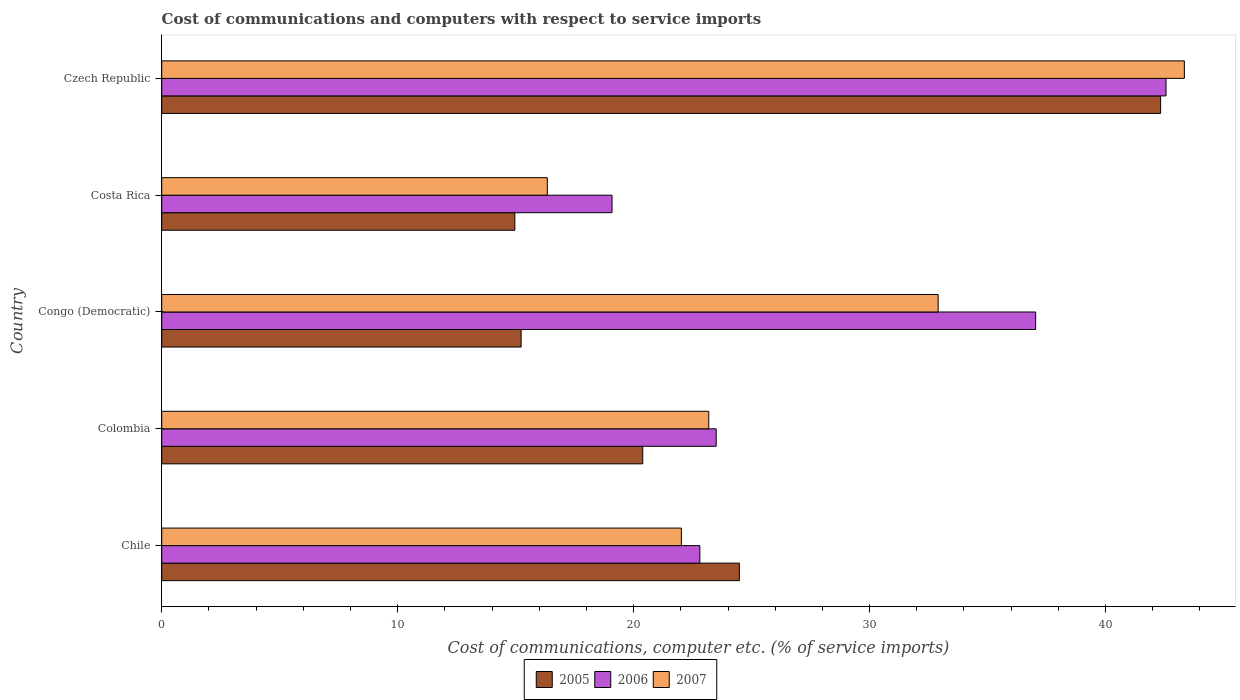How many different coloured bars are there?
Keep it short and to the point. 3. How many bars are there on the 3rd tick from the top?
Keep it short and to the point. 3. What is the label of the 5th group of bars from the top?
Your answer should be very brief. Chile. In how many cases, is the number of bars for a given country not equal to the number of legend labels?
Offer a terse response. 0. What is the cost of communications and computers in 2007 in Congo (Democratic)?
Provide a succinct answer. 32.91. Across all countries, what is the maximum cost of communications and computers in 2006?
Provide a short and direct response. 42.56. Across all countries, what is the minimum cost of communications and computers in 2007?
Keep it short and to the point. 16.34. In which country was the cost of communications and computers in 2007 maximum?
Offer a terse response. Czech Republic. In which country was the cost of communications and computers in 2006 minimum?
Give a very brief answer. Costa Rica. What is the total cost of communications and computers in 2006 in the graph?
Your answer should be compact. 145. What is the difference between the cost of communications and computers in 2006 in Chile and that in Congo (Democratic)?
Ensure brevity in your answer.  -14.23. What is the difference between the cost of communications and computers in 2006 in Czech Republic and the cost of communications and computers in 2007 in Costa Rica?
Your response must be concise. 26.22. What is the average cost of communications and computers in 2007 per country?
Your response must be concise. 27.56. What is the difference between the cost of communications and computers in 2005 and cost of communications and computers in 2006 in Colombia?
Make the answer very short. -3.11. In how many countries, is the cost of communications and computers in 2005 greater than 38 %?
Give a very brief answer. 1. What is the ratio of the cost of communications and computers in 2007 in Chile to that in Colombia?
Ensure brevity in your answer.  0.95. Is the cost of communications and computers in 2006 in Chile less than that in Costa Rica?
Offer a terse response. No. What is the difference between the highest and the second highest cost of communications and computers in 2007?
Offer a very short reply. 10.43. What is the difference between the highest and the lowest cost of communications and computers in 2005?
Provide a short and direct response. 27.37. In how many countries, is the cost of communications and computers in 2007 greater than the average cost of communications and computers in 2007 taken over all countries?
Provide a succinct answer. 2. Is the sum of the cost of communications and computers in 2005 in Colombia and Czech Republic greater than the maximum cost of communications and computers in 2006 across all countries?
Your answer should be compact. Yes. What does the 2nd bar from the top in Costa Rica represents?
Ensure brevity in your answer.  2006. Is it the case that in every country, the sum of the cost of communications and computers in 2005 and cost of communications and computers in 2007 is greater than the cost of communications and computers in 2006?
Your response must be concise. Yes. How many bars are there?
Keep it short and to the point. 15. Are all the bars in the graph horizontal?
Offer a very short reply. Yes. How many countries are there in the graph?
Offer a terse response. 5. What is the difference between two consecutive major ticks on the X-axis?
Give a very brief answer. 10. Does the graph contain any zero values?
Offer a very short reply. No. How many legend labels are there?
Provide a short and direct response. 3. What is the title of the graph?
Your answer should be very brief. Cost of communications and computers with respect to service imports. Does "1966" appear as one of the legend labels in the graph?
Your response must be concise. No. What is the label or title of the X-axis?
Offer a terse response. Cost of communications, computer etc. (% of service imports). What is the label or title of the Y-axis?
Offer a terse response. Country. What is the Cost of communications, computer etc. (% of service imports) of 2005 in Chile?
Provide a short and direct response. 24.48. What is the Cost of communications, computer etc. (% of service imports) of 2006 in Chile?
Ensure brevity in your answer.  22.81. What is the Cost of communications, computer etc. (% of service imports) in 2007 in Chile?
Make the answer very short. 22.02. What is the Cost of communications, computer etc. (% of service imports) in 2005 in Colombia?
Provide a short and direct response. 20.39. What is the Cost of communications, computer etc. (% of service imports) in 2006 in Colombia?
Make the answer very short. 23.5. What is the Cost of communications, computer etc. (% of service imports) of 2007 in Colombia?
Ensure brevity in your answer.  23.18. What is the Cost of communications, computer etc. (% of service imports) in 2005 in Congo (Democratic)?
Offer a terse response. 15.23. What is the Cost of communications, computer etc. (% of service imports) in 2006 in Congo (Democratic)?
Provide a short and direct response. 37.04. What is the Cost of communications, computer etc. (% of service imports) of 2007 in Congo (Democratic)?
Your response must be concise. 32.91. What is the Cost of communications, computer etc. (% of service imports) in 2005 in Costa Rica?
Offer a terse response. 14.97. What is the Cost of communications, computer etc. (% of service imports) of 2006 in Costa Rica?
Offer a very short reply. 19.09. What is the Cost of communications, computer etc. (% of service imports) in 2007 in Costa Rica?
Ensure brevity in your answer.  16.34. What is the Cost of communications, computer etc. (% of service imports) of 2005 in Czech Republic?
Give a very brief answer. 42.33. What is the Cost of communications, computer etc. (% of service imports) of 2006 in Czech Republic?
Offer a very short reply. 42.56. What is the Cost of communications, computer etc. (% of service imports) in 2007 in Czech Republic?
Make the answer very short. 43.34. Across all countries, what is the maximum Cost of communications, computer etc. (% of service imports) in 2005?
Your answer should be very brief. 42.33. Across all countries, what is the maximum Cost of communications, computer etc. (% of service imports) in 2006?
Keep it short and to the point. 42.56. Across all countries, what is the maximum Cost of communications, computer etc. (% of service imports) of 2007?
Offer a terse response. 43.34. Across all countries, what is the minimum Cost of communications, computer etc. (% of service imports) in 2005?
Your answer should be very brief. 14.97. Across all countries, what is the minimum Cost of communications, computer etc. (% of service imports) of 2006?
Give a very brief answer. 19.09. Across all countries, what is the minimum Cost of communications, computer etc. (% of service imports) of 2007?
Your answer should be compact. 16.34. What is the total Cost of communications, computer etc. (% of service imports) of 2005 in the graph?
Your answer should be compact. 117.4. What is the total Cost of communications, computer etc. (% of service imports) in 2006 in the graph?
Provide a succinct answer. 145. What is the total Cost of communications, computer etc. (% of service imports) in 2007 in the graph?
Your answer should be compact. 137.8. What is the difference between the Cost of communications, computer etc. (% of service imports) of 2005 in Chile and that in Colombia?
Your response must be concise. 4.09. What is the difference between the Cost of communications, computer etc. (% of service imports) of 2006 in Chile and that in Colombia?
Provide a short and direct response. -0.69. What is the difference between the Cost of communications, computer etc. (% of service imports) of 2007 in Chile and that in Colombia?
Keep it short and to the point. -1.16. What is the difference between the Cost of communications, computer etc. (% of service imports) in 2005 in Chile and that in Congo (Democratic)?
Keep it short and to the point. 9.25. What is the difference between the Cost of communications, computer etc. (% of service imports) in 2006 in Chile and that in Congo (Democratic)?
Give a very brief answer. -14.23. What is the difference between the Cost of communications, computer etc. (% of service imports) in 2007 in Chile and that in Congo (Democratic)?
Ensure brevity in your answer.  -10.88. What is the difference between the Cost of communications, computer etc. (% of service imports) of 2005 in Chile and that in Costa Rica?
Your answer should be compact. 9.52. What is the difference between the Cost of communications, computer etc. (% of service imports) in 2006 in Chile and that in Costa Rica?
Give a very brief answer. 3.72. What is the difference between the Cost of communications, computer etc. (% of service imports) of 2007 in Chile and that in Costa Rica?
Provide a short and direct response. 5.68. What is the difference between the Cost of communications, computer etc. (% of service imports) of 2005 in Chile and that in Czech Republic?
Ensure brevity in your answer.  -17.85. What is the difference between the Cost of communications, computer etc. (% of service imports) of 2006 in Chile and that in Czech Republic?
Ensure brevity in your answer.  -19.76. What is the difference between the Cost of communications, computer etc. (% of service imports) in 2007 in Chile and that in Czech Republic?
Offer a terse response. -21.32. What is the difference between the Cost of communications, computer etc. (% of service imports) of 2005 in Colombia and that in Congo (Democratic)?
Offer a terse response. 5.15. What is the difference between the Cost of communications, computer etc. (% of service imports) in 2006 in Colombia and that in Congo (Democratic)?
Make the answer very short. -13.54. What is the difference between the Cost of communications, computer etc. (% of service imports) of 2007 in Colombia and that in Congo (Democratic)?
Provide a short and direct response. -9.72. What is the difference between the Cost of communications, computer etc. (% of service imports) in 2005 in Colombia and that in Costa Rica?
Your answer should be very brief. 5.42. What is the difference between the Cost of communications, computer etc. (% of service imports) of 2006 in Colombia and that in Costa Rica?
Keep it short and to the point. 4.41. What is the difference between the Cost of communications, computer etc. (% of service imports) in 2007 in Colombia and that in Costa Rica?
Offer a terse response. 6.84. What is the difference between the Cost of communications, computer etc. (% of service imports) of 2005 in Colombia and that in Czech Republic?
Make the answer very short. -21.95. What is the difference between the Cost of communications, computer etc. (% of service imports) in 2006 in Colombia and that in Czech Republic?
Offer a terse response. -19.06. What is the difference between the Cost of communications, computer etc. (% of service imports) in 2007 in Colombia and that in Czech Republic?
Your answer should be compact. -20.16. What is the difference between the Cost of communications, computer etc. (% of service imports) in 2005 in Congo (Democratic) and that in Costa Rica?
Your response must be concise. 0.27. What is the difference between the Cost of communications, computer etc. (% of service imports) of 2006 in Congo (Democratic) and that in Costa Rica?
Provide a short and direct response. 17.95. What is the difference between the Cost of communications, computer etc. (% of service imports) of 2007 in Congo (Democratic) and that in Costa Rica?
Ensure brevity in your answer.  16.56. What is the difference between the Cost of communications, computer etc. (% of service imports) in 2005 in Congo (Democratic) and that in Czech Republic?
Make the answer very short. -27.1. What is the difference between the Cost of communications, computer etc. (% of service imports) of 2006 in Congo (Democratic) and that in Czech Republic?
Keep it short and to the point. -5.53. What is the difference between the Cost of communications, computer etc. (% of service imports) in 2007 in Congo (Democratic) and that in Czech Republic?
Your response must be concise. -10.43. What is the difference between the Cost of communications, computer etc. (% of service imports) in 2005 in Costa Rica and that in Czech Republic?
Ensure brevity in your answer.  -27.37. What is the difference between the Cost of communications, computer etc. (% of service imports) in 2006 in Costa Rica and that in Czech Republic?
Provide a succinct answer. -23.48. What is the difference between the Cost of communications, computer etc. (% of service imports) in 2007 in Costa Rica and that in Czech Republic?
Make the answer very short. -27. What is the difference between the Cost of communications, computer etc. (% of service imports) of 2005 in Chile and the Cost of communications, computer etc. (% of service imports) of 2006 in Colombia?
Your answer should be very brief. 0.98. What is the difference between the Cost of communications, computer etc. (% of service imports) in 2005 in Chile and the Cost of communications, computer etc. (% of service imports) in 2007 in Colombia?
Offer a very short reply. 1.3. What is the difference between the Cost of communications, computer etc. (% of service imports) of 2006 in Chile and the Cost of communications, computer etc. (% of service imports) of 2007 in Colombia?
Give a very brief answer. -0.38. What is the difference between the Cost of communications, computer etc. (% of service imports) of 2005 in Chile and the Cost of communications, computer etc. (% of service imports) of 2006 in Congo (Democratic)?
Ensure brevity in your answer.  -12.56. What is the difference between the Cost of communications, computer etc. (% of service imports) of 2005 in Chile and the Cost of communications, computer etc. (% of service imports) of 2007 in Congo (Democratic)?
Your response must be concise. -8.43. What is the difference between the Cost of communications, computer etc. (% of service imports) in 2006 in Chile and the Cost of communications, computer etc. (% of service imports) in 2007 in Congo (Democratic)?
Your answer should be very brief. -10.1. What is the difference between the Cost of communications, computer etc. (% of service imports) in 2005 in Chile and the Cost of communications, computer etc. (% of service imports) in 2006 in Costa Rica?
Keep it short and to the point. 5.4. What is the difference between the Cost of communications, computer etc. (% of service imports) in 2005 in Chile and the Cost of communications, computer etc. (% of service imports) in 2007 in Costa Rica?
Keep it short and to the point. 8.14. What is the difference between the Cost of communications, computer etc. (% of service imports) in 2006 in Chile and the Cost of communications, computer etc. (% of service imports) in 2007 in Costa Rica?
Provide a succinct answer. 6.46. What is the difference between the Cost of communications, computer etc. (% of service imports) of 2005 in Chile and the Cost of communications, computer etc. (% of service imports) of 2006 in Czech Republic?
Make the answer very short. -18.08. What is the difference between the Cost of communications, computer etc. (% of service imports) in 2005 in Chile and the Cost of communications, computer etc. (% of service imports) in 2007 in Czech Republic?
Your answer should be very brief. -18.86. What is the difference between the Cost of communications, computer etc. (% of service imports) of 2006 in Chile and the Cost of communications, computer etc. (% of service imports) of 2007 in Czech Republic?
Ensure brevity in your answer.  -20.53. What is the difference between the Cost of communications, computer etc. (% of service imports) in 2005 in Colombia and the Cost of communications, computer etc. (% of service imports) in 2006 in Congo (Democratic)?
Offer a terse response. -16.65. What is the difference between the Cost of communications, computer etc. (% of service imports) in 2005 in Colombia and the Cost of communications, computer etc. (% of service imports) in 2007 in Congo (Democratic)?
Provide a short and direct response. -12.52. What is the difference between the Cost of communications, computer etc. (% of service imports) of 2006 in Colombia and the Cost of communications, computer etc. (% of service imports) of 2007 in Congo (Democratic)?
Provide a short and direct response. -9.41. What is the difference between the Cost of communications, computer etc. (% of service imports) of 2005 in Colombia and the Cost of communications, computer etc. (% of service imports) of 2006 in Costa Rica?
Offer a very short reply. 1.3. What is the difference between the Cost of communications, computer etc. (% of service imports) in 2005 in Colombia and the Cost of communications, computer etc. (% of service imports) in 2007 in Costa Rica?
Provide a succinct answer. 4.04. What is the difference between the Cost of communications, computer etc. (% of service imports) of 2006 in Colombia and the Cost of communications, computer etc. (% of service imports) of 2007 in Costa Rica?
Offer a very short reply. 7.16. What is the difference between the Cost of communications, computer etc. (% of service imports) of 2005 in Colombia and the Cost of communications, computer etc. (% of service imports) of 2006 in Czech Republic?
Give a very brief answer. -22.18. What is the difference between the Cost of communications, computer etc. (% of service imports) of 2005 in Colombia and the Cost of communications, computer etc. (% of service imports) of 2007 in Czech Republic?
Give a very brief answer. -22.95. What is the difference between the Cost of communications, computer etc. (% of service imports) of 2006 in Colombia and the Cost of communications, computer etc. (% of service imports) of 2007 in Czech Republic?
Give a very brief answer. -19.84. What is the difference between the Cost of communications, computer etc. (% of service imports) of 2005 in Congo (Democratic) and the Cost of communications, computer etc. (% of service imports) of 2006 in Costa Rica?
Your response must be concise. -3.85. What is the difference between the Cost of communications, computer etc. (% of service imports) of 2005 in Congo (Democratic) and the Cost of communications, computer etc. (% of service imports) of 2007 in Costa Rica?
Make the answer very short. -1.11. What is the difference between the Cost of communications, computer etc. (% of service imports) in 2006 in Congo (Democratic) and the Cost of communications, computer etc. (% of service imports) in 2007 in Costa Rica?
Offer a very short reply. 20.7. What is the difference between the Cost of communications, computer etc. (% of service imports) of 2005 in Congo (Democratic) and the Cost of communications, computer etc. (% of service imports) of 2006 in Czech Republic?
Keep it short and to the point. -27.33. What is the difference between the Cost of communications, computer etc. (% of service imports) in 2005 in Congo (Democratic) and the Cost of communications, computer etc. (% of service imports) in 2007 in Czech Republic?
Offer a very short reply. -28.11. What is the difference between the Cost of communications, computer etc. (% of service imports) in 2006 in Congo (Democratic) and the Cost of communications, computer etc. (% of service imports) in 2007 in Czech Republic?
Your answer should be very brief. -6.3. What is the difference between the Cost of communications, computer etc. (% of service imports) in 2005 in Costa Rica and the Cost of communications, computer etc. (% of service imports) in 2006 in Czech Republic?
Your answer should be very brief. -27.6. What is the difference between the Cost of communications, computer etc. (% of service imports) in 2005 in Costa Rica and the Cost of communications, computer etc. (% of service imports) in 2007 in Czech Republic?
Keep it short and to the point. -28.38. What is the difference between the Cost of communications, computer etc. (% of service imports) in 2006 in Costa Rica and the Cost of communications, computer etc. (% of service imports) in 2007 in Czech Republic?
Offer a terse response. -24.26. What is the average Cost of communications, computer etc. (% of service imports) in 2005 per country?
Offer a terse response. 23.48. What is the average Cost of communications, computer etc. (% of service imports) of 2006 per country?
Give a very brief answer. 29. What is the average Cost of communications, computer etc. (% of service imports) in 2007 per country?
Your answer should be very brief. 27.56. What is the difference between the Cost of communications, computer etc. (% of service imports) of 2005 and Cost of communications, computer etc. (% of service imports) of 2006 in Chile?
Ensure brevity in your answer.  1.67. What is the difference between the Cost of communications, computer etc. (% of service imports) of 2005 and Cost of communications, computer etc. (% of service imports) of 2007 in Chile?
Make the answer very short. 2.46. What is the difference between the Cost of communications, computer etc. (% of service imports) of 2006 and Cost of communications, computer etc. (% of service imports) of 2007 in Chile?
Offer a very short reply. 0.78. What is the difference between the Cost of communications, computer etc. (% of service imports) of 2005 and Cost of communications, computer etc. (% of service imports) of 2006 in Colombia?
Provide a succinct answer. -3.11. What is the difference between the Cost of communications, computer etc. (% of service imports) in 2005 and Cost of communications, computer etc. (% of service imports) in 2007 in Colombia?
Your answer should be compact. -2.8. What is the difference between the Cost of communications, computer etc. (% of service imports) in 2006 and Cost of communications, computer etc. (% of service imports) in 2007 in Colombia?
Provide a short and direct response. 0.32. What is the difference between the Cost of communications, computer etc. (% of service imports) of 2005 and Cost of communications, computer etc. (% of service imports) of 2006 in Congo (Democratic)?
Make the answer very short. -21.81. What is the difference between the Cost of communications, computer etc. (% of service imports) of 2005 and Cost of communications, computer etc. (% of service imports) of 2007 in Congo (Democratic)?
Offer a very short reply. -17.67. What is the difference between the Cost of communications, computer etc. (% of service imports) in 2006 and Cost of communications, computer etc. (% of service imports) in 2007 in Congo (Democratic)?
Make the answer very short. 4.13. What is the difference between the Cost of communications, computer etc. (% of service imports) of 2005 and Cost of communications, computer etc. (% of service imports) of 2006 in Costa Rica?
Make the answer very short. -4.12. What is the difference between the Cost of communications, computer etc. (% of service imports) in 2005 and Cost of communications, computer etc. (% of service imports) in 2007 in Costa Rica?
Provide a short and direct response. -1.38. What is the difference between the Cost of communications, computer etc. (% of service imports) of 2006 and Cost of communications, computer etc. (% of service imports) of 2007 in Costa Rica?
Your answer should be very brief. 2.74. What is the difference between the Cost of communications, computer etc. (% of service imports) of 2005 and Cost of communications, computer etc. (% of service imports) of 2006 in Czech Republic?
Provide a short and direct response. -0.23. What is the difference between the Cost of communications, computer etc. (% of service imports) of 2005 and Cost of communications, computer etc. (% of service imports) of 2007 in Czech Republic?
Give a very brief answer. -1.01. What is the difference between the Cost of communications, computer etc. (% of service imports) of 2006 and Cost of communications, computer etc. (% of service imports) of 2007 in Czech Republic?
Make the answer very short. -0.78. What is the ratio of the Cost of communications, computer etc. (% of service imports) in 2005 in Chile to that in Colombia?
Provide a succinct answer. 1.2. What is the ratio of the Cost of communications, computer etc. (% of service imports) of 2006 in Chile to that in Colombia?
Make the answer very short. 0.97. What is the ratio of the Cost of communications, computer etc. (% of service imports) of 2005 in Chile to that in Congo (Democratic)?
Ensure brevity in your answer.  1.61. What is the ratio of the Cost of communications, computer etc. (% of service imports) of 2006 in Chile to that in Congo (Democratic)?
Ensure brevity in your answer.  0.62. What is the ratio of the Cost of communications, computer etc. (% of service imports) in 2007 in Chile to that in Congo (Democratic)?
Ensure brevity in your answer.  0.67. What is the ratio of the Cost of communications, computer etc. (% of service imports) in 2005 in Chile to that in Costa Rica?
Ensure brevity in your answer.  1.64. What is the ratio of the Cost of communications, computer etc. (% of service imports) of 2006 in Chile to that in Costa Rica?
Offer a terse response. 1.2. What is the ratio of the Cost of communications, computer etc. (% of service imports) of 2007 in Chile to that in Costa Rica?
Your answer should be compact. 1.35. What is the ratio of the Cost of communications, computer etc. (% of service imports) of 2005 in Chile to that in Czech Republic?
Make the answer very short. 0.58. What is the ratio of the Cost of communications, computer etc. (% of service imports) of 2006 in Chile to that in Czech Republic?
Give a very brief answer. 0.54. What is the ratio of the Cost of communications, computer etc. (% of service imports) of 2007 in Chile to that in Czech Republic?
Offer a very short reply. 0.51. What is the ratio of the Cost of communications, computer etc. (% of service imports) of 2005 in Colombia to that in Congo (Democratic)?
Provide a succinct answer. 1.34. What is the ratio of the Cost of communications, computer etc. (% of service imports) in 2006 in Colombia to that in Congo (Democratic)?
Provide a short and direct response. 0.63. What is the ratio of the Cost of communications, computer etc. (% of service imports) in 2007 in Colombia to that in Congo (Democratic)?
Keep it short and to the point. 0.7. What is the ratio of the Cost of communications, computer etc. (% of service imports) of 2005 in Colombia to that in Costa Rica?
Ensure brevity in your answer.  1.36. What is the ratio of the Cost of communications, computer etc. (% of service imports) of 2006 in Colombia to that in Costa Rica?
Make the answer very short. 1.23. What is the ratio of the Cost of communications, computer etc. (% of service imports) of 2007 in Colombia to that in Costa Rica?
Provide a short and direct response. 1.42. What is the ratio of the Cost of communications, computer etc. (% of service imports) in 2005 in Colombia to that in Czech Republic?
Offer a terse response. 0.48. What is the ratio of the Cost of communications, computer etc. (% of service imports) of 2006 in Colombia to that in Czech Republic?
Your answer should be very brief. 0.55. What is the ratio of the Cost of communications, computer etc. (% of service imports) of 2007 in Colombia to that in Czech Republic?
Provide a short and direct response. 0.53. What is the ratio of the Cost of communications, computer etc. (% of service imports) of 2005 in Congo (Democratic) to that in Costa Rica?
Ensure brevity in your answer.  1.02. What is the ratio of the Cost of communications, computer etc. (% of service imports) of 2006 in Congo (Democratic) to that in Costa Rica?
Provide a short and direct response. 1.94. What is the ratio of the Cost of communications, computer etc. (% of service imports) in 2007 in Congo (Democratic) to that in Costa Rica?
Provide a short and direct response. 2.01. What is the ratio of the Cost of communications, computer etc. (% of service imports) of 2005 in Congo (Democratic) to that in Czech Republic?
Give a very brief answer. 0.36. What is the ratio of the Cost of communications, computer etc. (% of service imports) in 2006 in Congo (Democratic) to that in Czech Republic?
Make the answer very short. 0.87. What is the ratio of the Cost of communications, computer etc. (% of service imports) of 2007 in Congo (Democratic) to that in Czech Republic?
Offer a very short reply. 0.76. What is the ratio of the Cost of communications, computer etc. (% of service imports) in 2005 in Costa Rica to that in Czech Republic?
Ensure brevity in your answer.  0.35. What is the ratio of the Cost of communications, computer etc. (% of service imports) in 2006 in Costa Rica to that in Czech Republic?
Offer a terse response. 0.45. What is the ratio of the Cost of communications, computer etc. (% of service imports) in 2007 in Costa Rica to that in Czech Republic?
Your answer should be very brief. 0.38. What is the difference between the highest and the second highest Cost of communications, computer etc. (% of service imports) in 2005?
Keep it short and to the point. 17.85. What is the difference between the highest and the second highest Cost of communications, computer etc. (% of service imports) of 2006?
Your answer should be very brief. 5.53. What is the difference between the highest and the second highest Cost of communications, computer etc. (% of service imports) of 2007?
Your answer should be compact. 10.43. What is the difference between the highest and the lowest Cost of communications, computer etc. (% of service imports) in 2005?
Your answer should be compact. 27.37. What is the difference between the highest and the lowest Cost of communications, computer etc. (% of service imports) of 2006?
Keep it short and to the point. 23.48. What is the difference between the highest and the lowest Cost of communications, computer etc. (% of service imports) of 2007?
Your answer should be very brief. 27. 